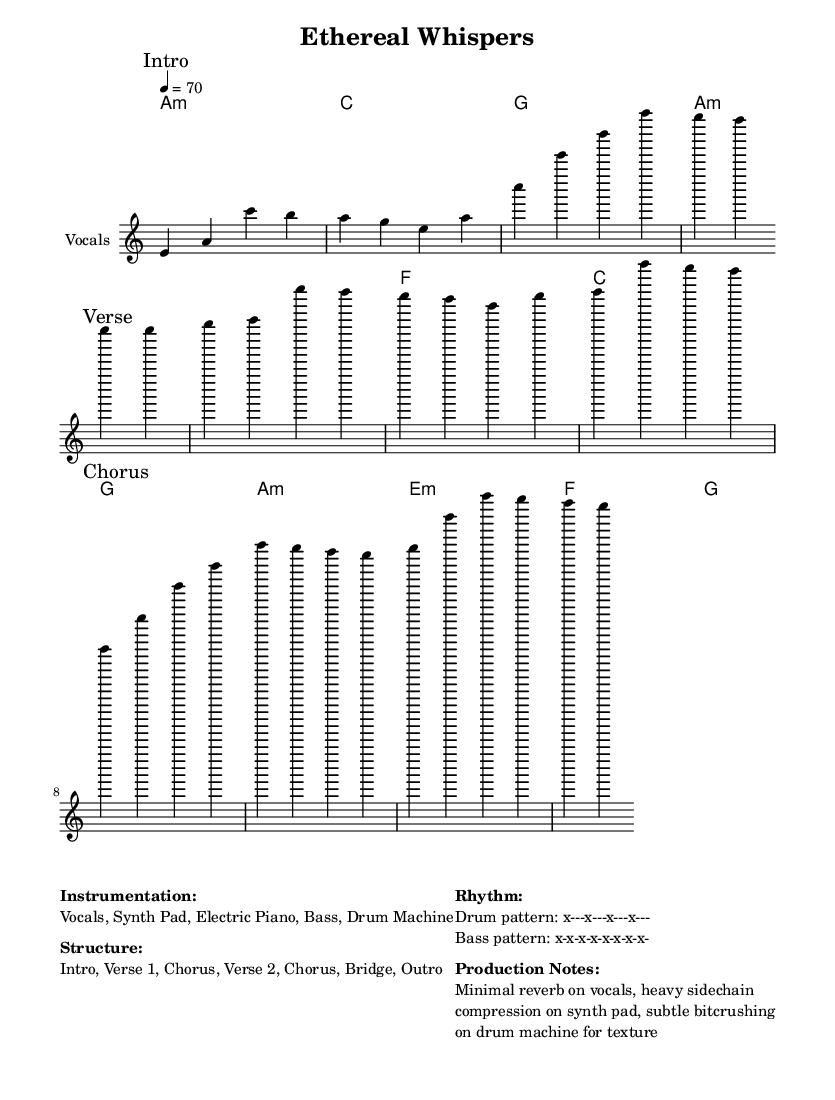What is the key signature of this music? The key signature is A minor, which is indicated by the presence of no sharps or flats. This can be inferred from the global section of the code where "\key a \minor" is specified.
Answer: A minor What is the time signature of the piece? The time signature is 4/4, which means there are four beats in each measure and the quarter note takes one beat. This is also noted in the global section with "\time 4/4".
Answer: 4/4 What is the tempo of the music? The tempo is specified as quarter note equals 70 beats per minute, noted as "4 = 70" in the global section. This indicates the speed at which the music should be played.
Answer: 70 How many sections does the song have? The structure provided indicates there are six sections: Intro, Verse 1, Chorus, Verse 2, Chorus, Bridge, and Outro. This can be found under "Structure" in the markup section.
Answer: 6 What is the main characteristic of the rhythm noted in the score? The drum pattern is indicated as "x---x---x---x---", which reflects a basic backbeat commonly used in R&B music. This is listed under "Rhythm" in the markup section, showing its simplicity and repetition.
Answer: x---x---x---x--- What types of instruments are involved in the composition? The instrumentation includes Vocals, Synth Pad, Electric Piano, Bass, and Drum Machine. This information is clearly provided under "Instrumentation" in the markup section.
Answer: Vocals, Synth Pad, Electric Piano, Bass, Drum Machine What production technique is applied to the vocals? The production notes indicate that minimal reverb is applied to the vocals. This suggests a clearer and more present vocal sound, which is typical in R&B to showcase soulful singing. This detail can be found under "Production Notes".
Answer: Minimal reverb 